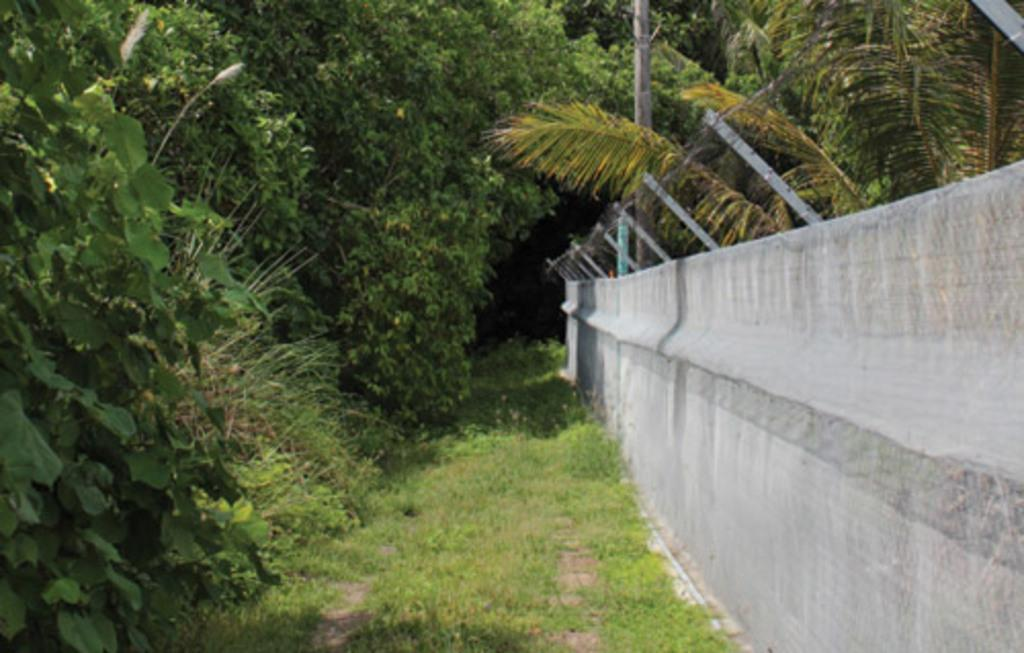What type of vegetation is on the left side of the image? There are trees on the left side of the image. What is on the ground beneath the trees on the left side of the image? There is grass on the ground on the left side of the image. What is located on the right side of the image? There is a fence on the right side of the image, and it has a wall associated with it. What can be seen in the background of the image? There is a pole and trees in the background of the image. Can you tell me how many giraffes are standing near the fence in the image? There are no giraffes present in the image. What color is the silver giraffe in the image? There is no silver giraffe in the image, as there are no giraffes present. 